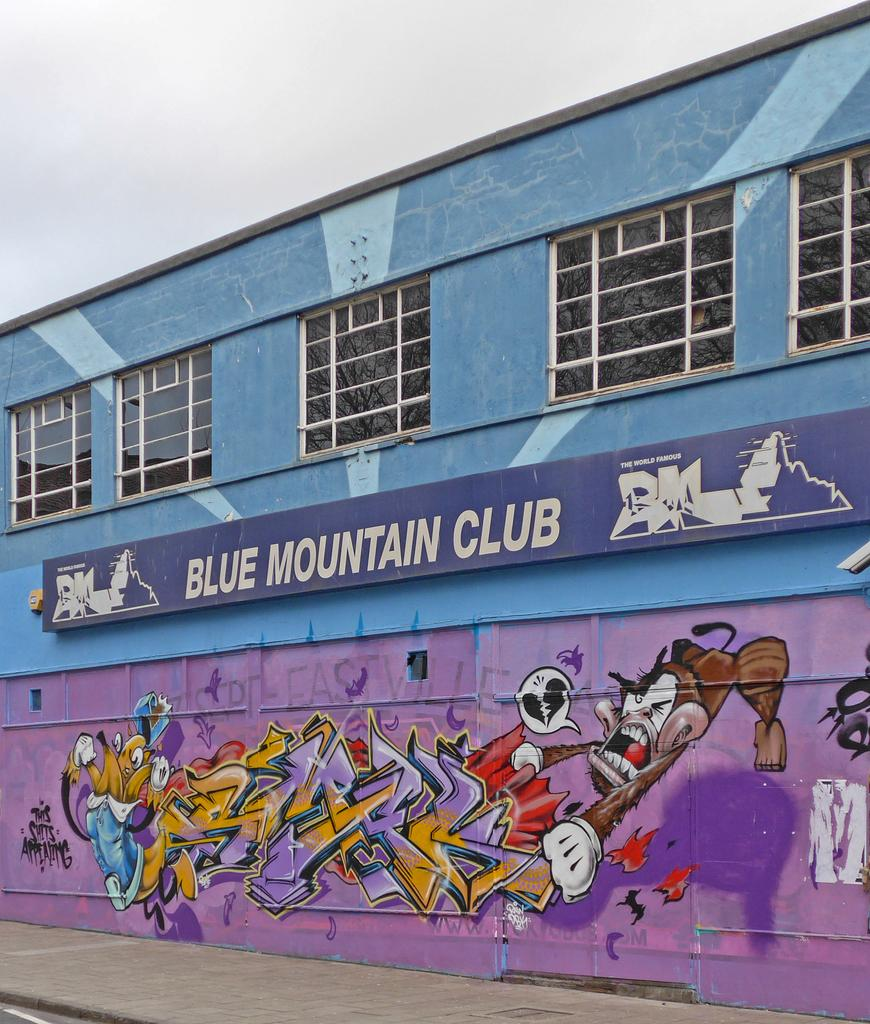<image>
Summarize the visual content of the image. Purple sign that says Blue Mountain Club outside of a building. 